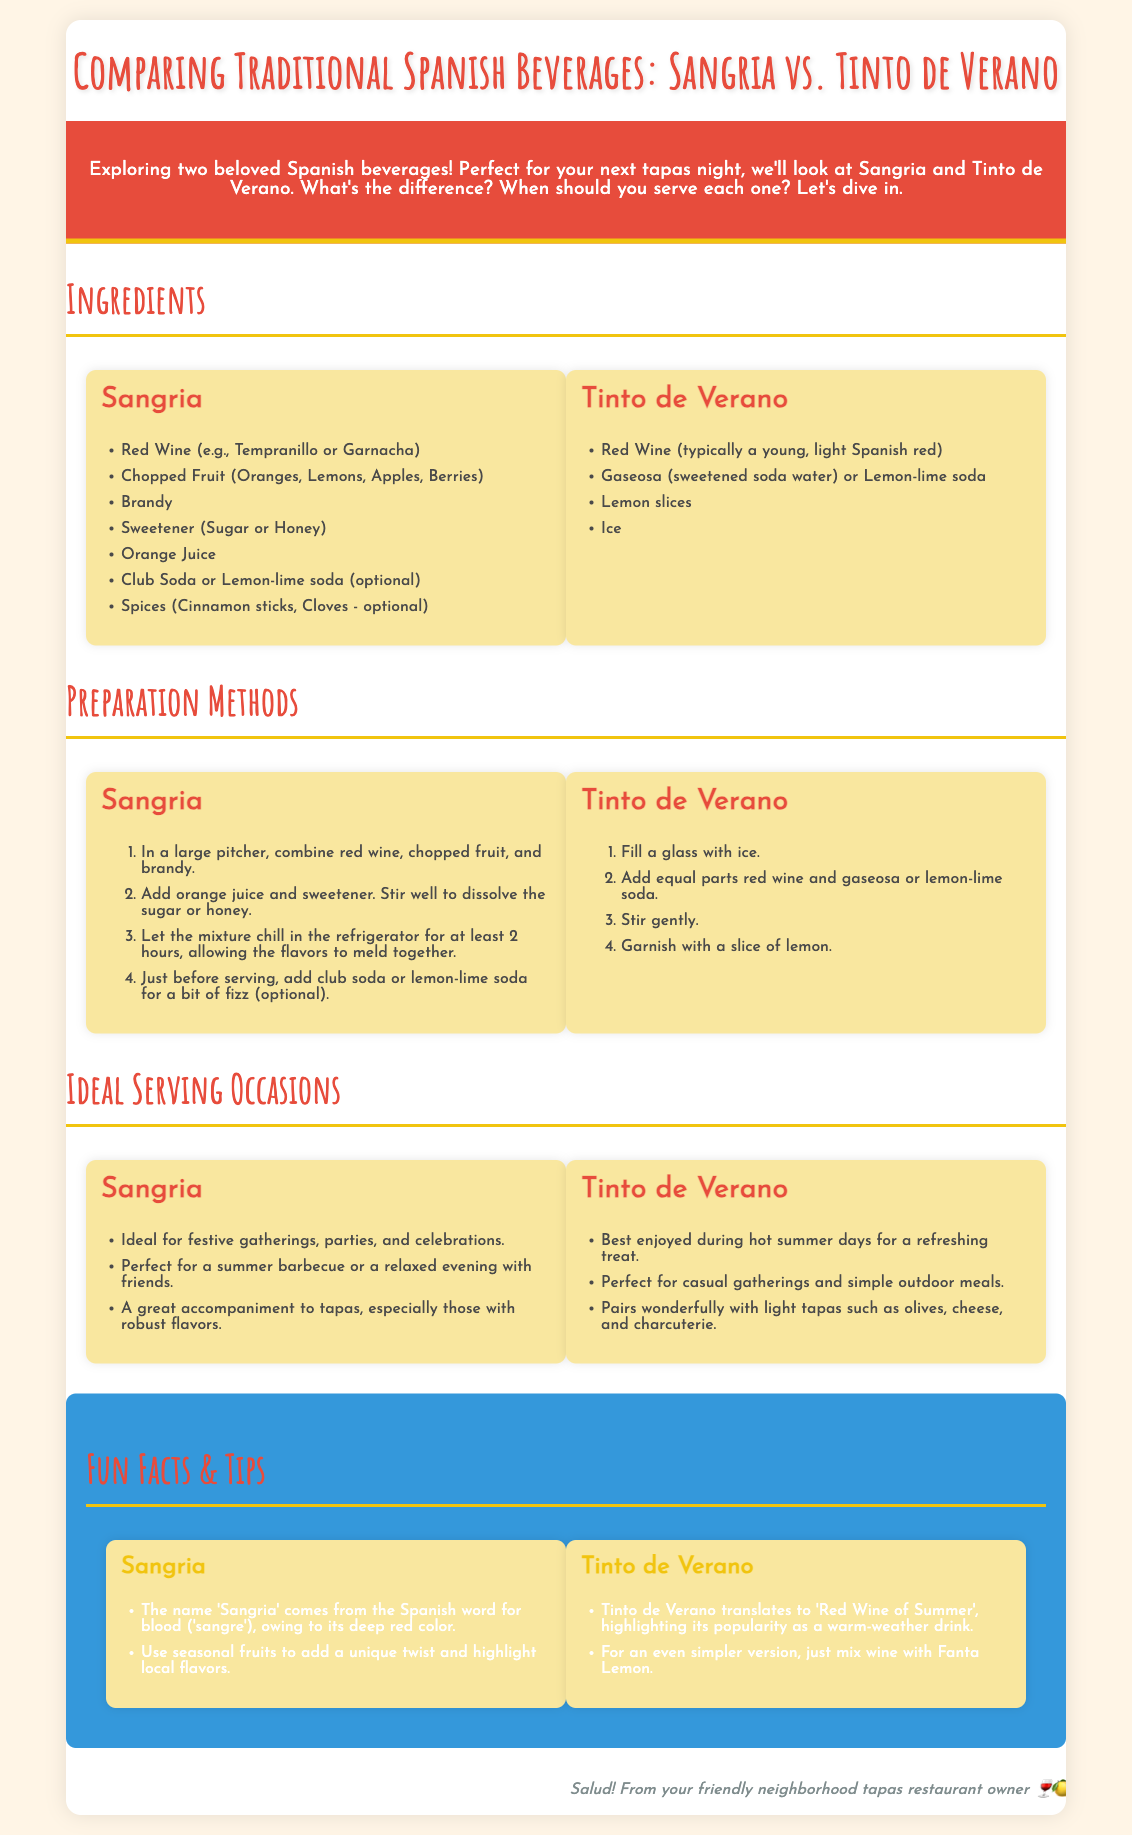What ingredients are used in Sangria? The document lists several ingredients for Sangria, including red wine, chopped fruit, brandy, sweetener, orange juice, club soda, and optional spices.
Answer: Red Wine, Chopped Fruit, Brandy, Sweetener, Orange Juice, Club Soda, Spices What is the primary sweetener used in Tinto de Verano? The Tinto de Verano primarily uses gaseosa or lemon-lime soda as its sweetener.
Answer: Gaseosa How long should Sangria chill before serving? The document states that Sangria should chill in the refrigerator for at least 2 hours.
Answer: 2 hours What type of wine is typically used in Tinto de Verano? The document mentions that a young, light Spanish red wine is typically used in Tinto de Verano.
Answer: Young, Light Spanish Red What is a fun fact about Sangria? According to the document, one fun fact is that the name 'Sangria' comes from the Spanish word for blood ('sangre').
Answer: 'Sangre' Which beverage is best for hot summer days? The document states that Tinto de Verano is best enjoyed during hot summer days.
Answer: Tinto de Verano What preparation step follows combining wine and chopped fruit for Sangria? After combining, the next step is to add orange juice and sweetener, stirring well.
Answer: Add orange juice and sweetener What type of occasions is Sangria ideal for? The document suggests Sangria is ideal for festive gatherings, parties, and celebrations.
Answer: Festive gatherings Which drink translates to 'Red Wine of Summer'? The document reveals that the term Tinto de Verano translates to 'Red Wine of Summer'.
Answer: Tinto de Verano 